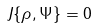<formula> <loc_0><loc_0><loc_500><loc_500>J \{ \rho , \Psi \} = 0</formula> 